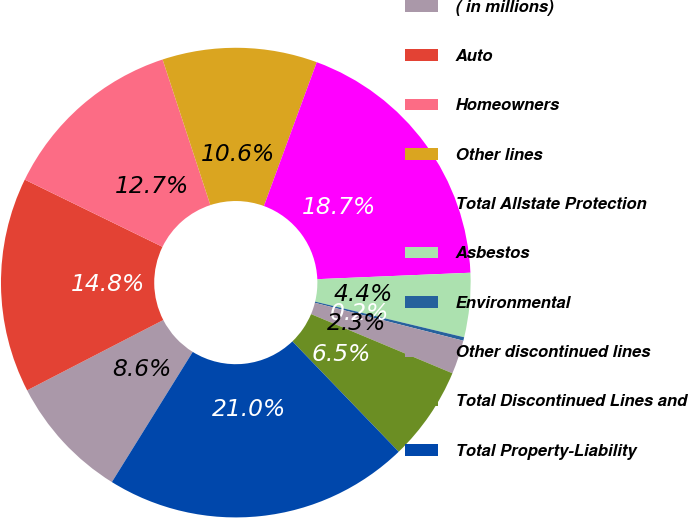Convert chart to OTSL. <chart><loc_0><loc_0><loc_500><loc_500><pie_chart><fcel>( in millions)<fcel>Auto<fcel>Homeowners<fcel>Other lines<fcel>Total Allstate Protection<fcel>Asbestos<fcel>Environmental<fcel>Other discontinued lines<fcel>Total Discontinued Lines and<fcel>Total Property-Liability<nl><fcel>8.57%<fcel>14.81%<fcel>12.73%<fcel>10.65%<fcel>18.73%<fcel>4.41%<fcel>0.24%<fcel>2.33%<fcel>6.49%<fcel>21.05%<nl></chart> 